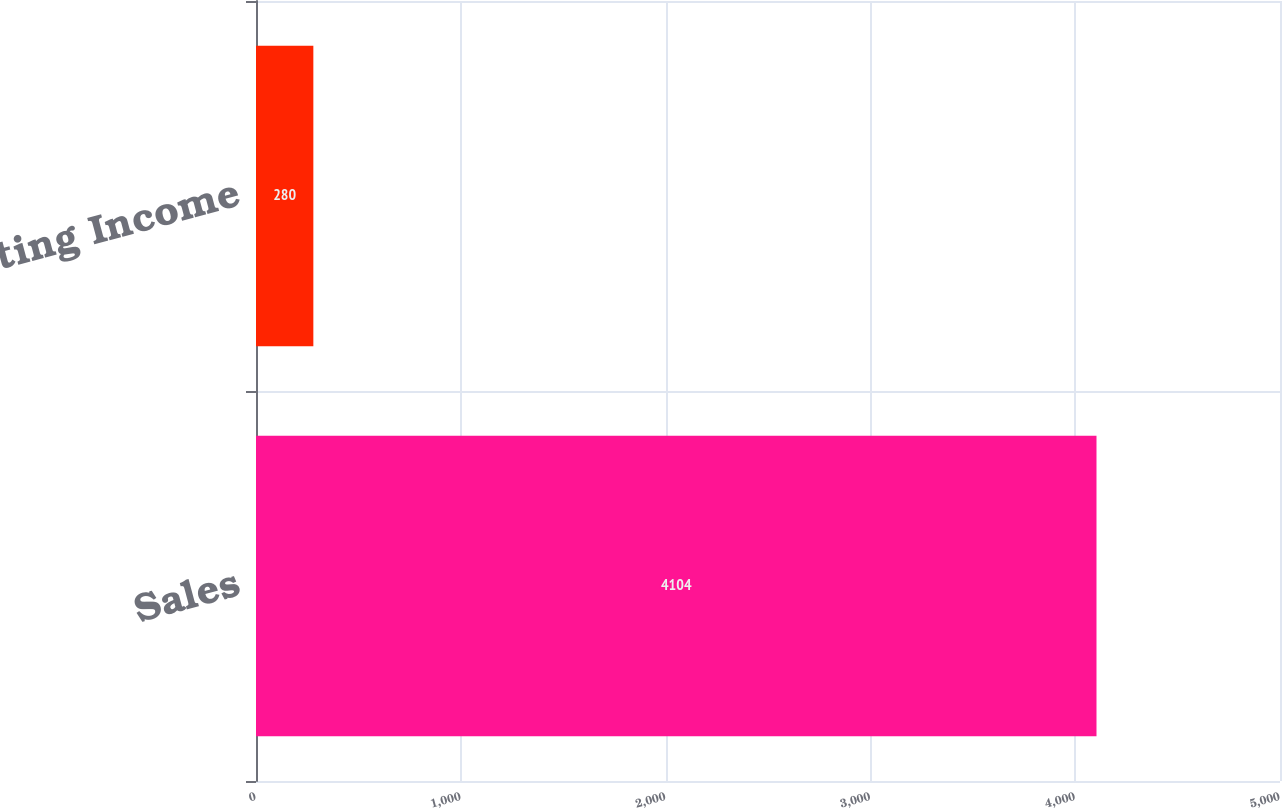Convert chart. <chart><loc_0><loc_0><loc_500><loc_500><bar_chart><fcel>Sales<fcel>Operating Income<nl><fcel>4104<fcel>280<nl></chart> 